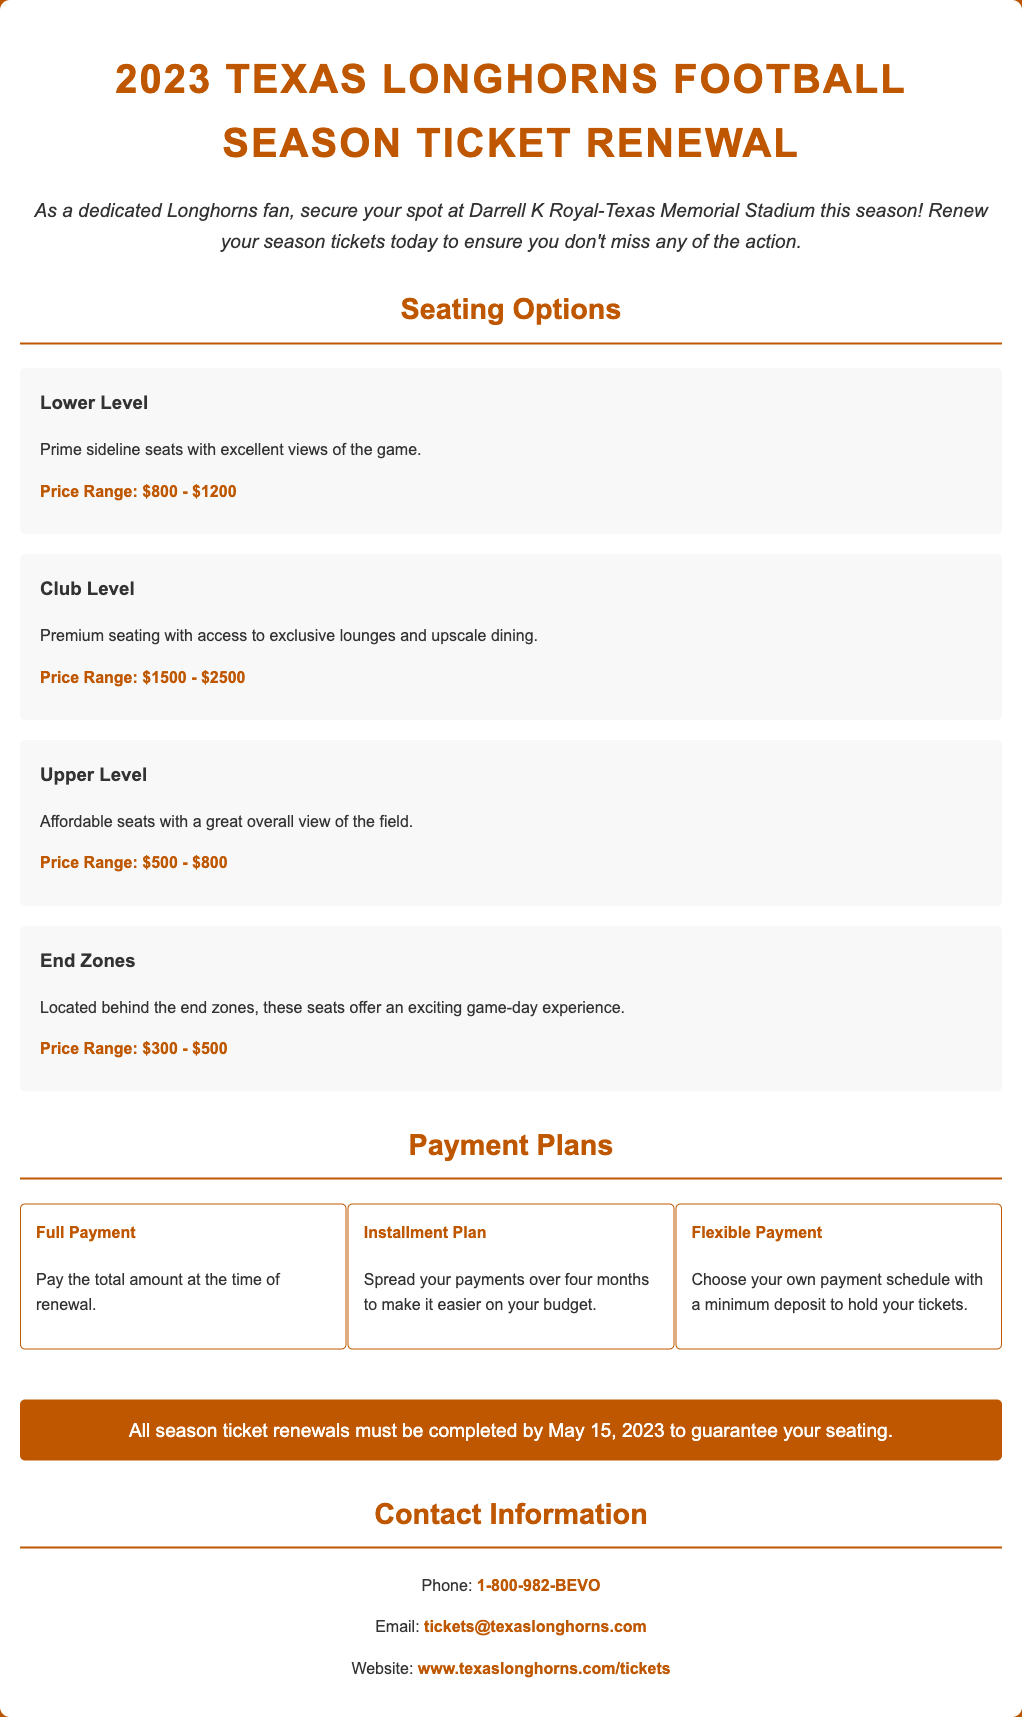What is the price range for Lower Level seats? The price range for Lower Level seats is specified under the seating options.
Answer: $800 - $1200 What is the deadline for season ticket renewals? The document mentions the deadline for completing season ticket renewals to guarantee seating.
Answer: May 15, 2023 What payment plan allows you to pay the total amount at once? The document outlines different payment plans, and this one is explicitly described.
Answer: Full Payment What is included with Club Level seating? The Club Level section details what features come with that seating option.
Answer: Access to exclusive lounges and upscale dining What is the price range for End Zone seats? The price range for End Zone seats is found in the seating options section.
Answer: $300 - $500 